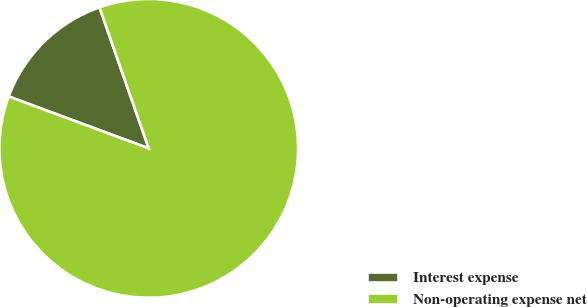Convert chart to OTSL. <chart><loc_0><loc_0><loc_500><loc_500><pie_chart><fcel>Interest expense<fcel>Non-operating expense net<nl><fcel>14.0%<fcel>86.0%<nl></chart> 